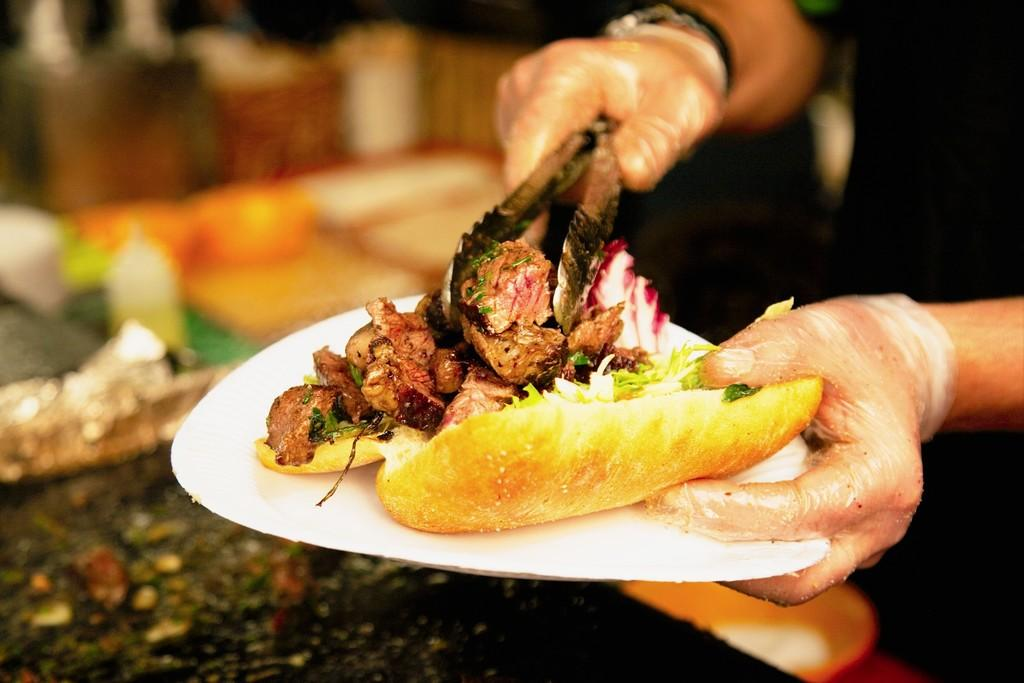What is the main subject of the image? There is a person in the image. What is the person doing with one hand? The person is holding a food item with one hand. What is the person doing with their other hand? The person is holding their tongue with another hand. Can you describe the background of the image? The background of the image is blurred. How many kittens can be seen playing with the food item in the image? There are no kittens present in the image. Are the person's brothers also in the image? The provided facts do not mention any brothers, so we cannot determine if they are present in the image. 